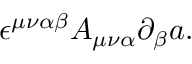Convert formula to latex. <formula><loc_0><loc_0><loc_500><loc_500>\epsilon ^ { \mu \nu \alpha \beta } A _ { \mu \nu \alpha } \partial _ { \beta } a .</formula> 